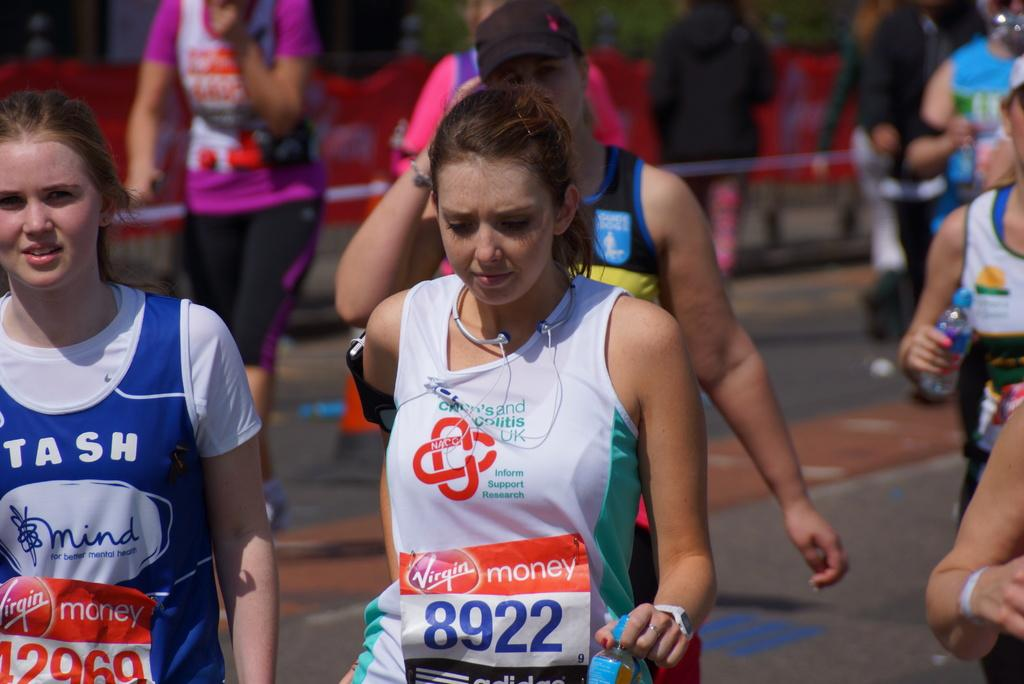What are the women in the image doing? The women in the image are walking. What are some of the women holding while walking? Some of the women are holding water bottles. Can you describe the background of the image? There are people visible in the background of the image. What is the price of the glove in the image? There is no glove present in the image, so it is not possible to determine its price. 